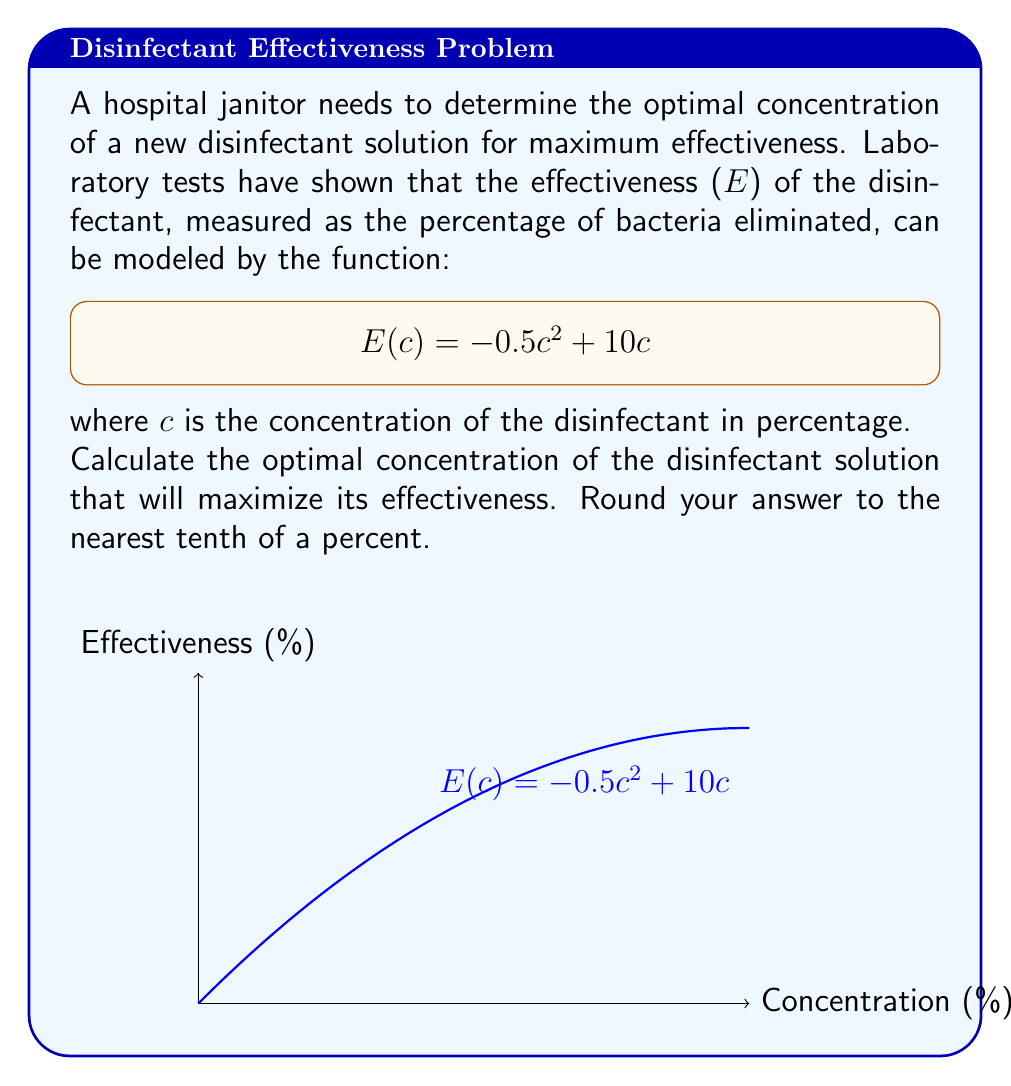Teach me how to tackle this problem. To find the optimal concentration, we need to maximize the effectiveness function E(c). This can be done by finding the critical point of the function.

Step 1: Find the derivative of E(c)
$$E'(c) = \frac{d}{dc}(-0.5c^2 + 10c) = -c + 10$$

Step 2: Set the derivative equal to zero and solve for c
$$E'(c) = 0$$
$$-c + 10 = 0$$
$$c = 10$$

Step 3: Verify this is a maximum by checking the second derivative
$$E''(c) = \frac{d}{dc}(-c + 10) = -1$$

Since E''(c) is negative, the critical point is a maximum.

Step 4: Calculate the effectiveness at the optimal concentration
$$E(10) = -0.5(10)^2 + 10(10) = -50 + 100 = 50$$

Therefore, the optimal concentration is 10%, which yields a maximum effectiveness of 50%.

Step 5: Round to the nearest tenth of a percent
10% rounded to the nearest tenth is 10.0%.
Answer: 10.0% 